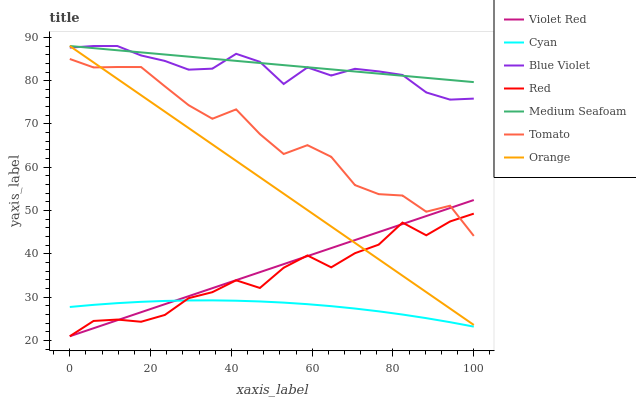Does Cyan have the minimum area under the curve?
Answer yes or no. Yes. Does Medium Seafoam have the maximum area under the curve?
Answer yes or no. Yes. Does Violet Red have the minimum area under the curve?
Answer yes or no. No. Does Violet Red have the maximum area under the curve?
Answer yes or no. No. Is Orange the smoothest?
Answer yes or no. Yes. Is Tomato the roughest?
Answer yes or no. Yes. Is Violet Red the smoothest?
Answer yes or no. No. Is Violet Red the roughest?
Answer yes or no. No. Does Violet Red have the lowest value?
Answer yes or no. Yes. Does Blue Violet have the lowest value?
Answer yes or no. No. Does Medium Seafoam have the highest value?
Answer yes or no. Yes. Does Violet Red have the highest value?
Answer yes or no. No. Is Cyan less than Blue Violet?
Answer yes or no. Yes. Is Medium Seafoam greater than Violet Red?
Answer yes or no. Yes. Does Violet Red intersect Cyan?
Answer yes or no. Yes. Is Violet Red less than Cyan?
Answer yes or no. No. Is Violet Red greater than Cyan?
Answer yes or no. No. Does Cyan intersect Blue Violet?
Answer yes or no. No. 